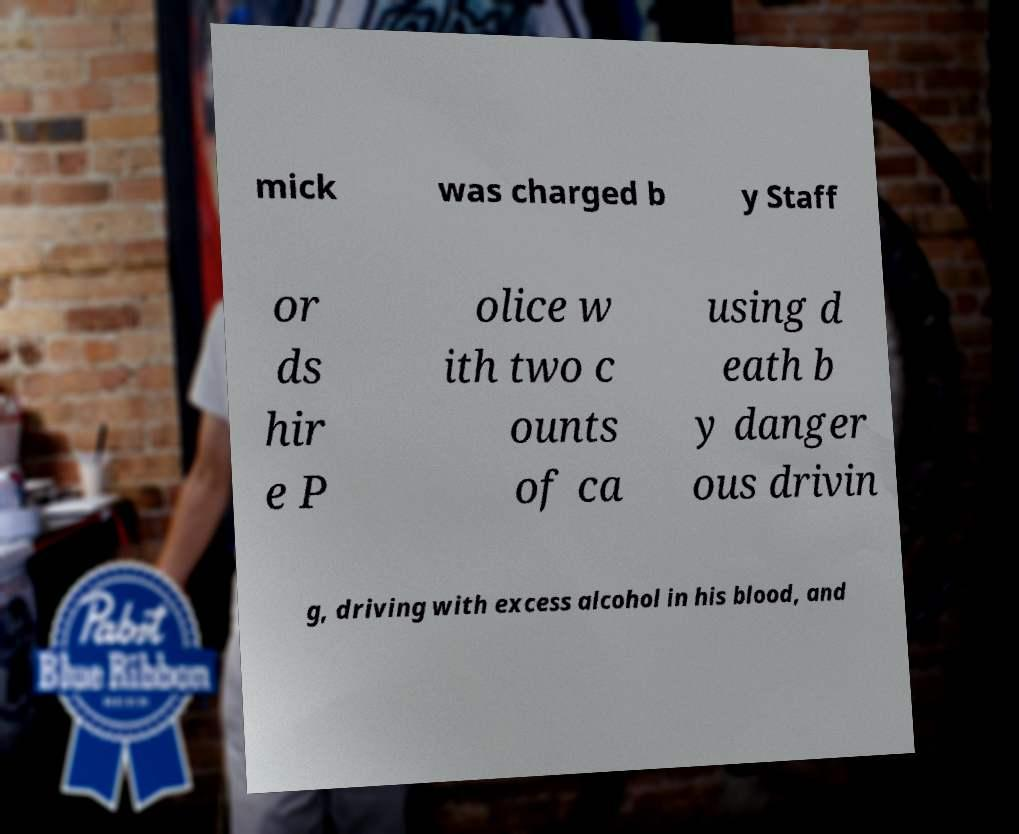Please identify and transcribe the text found in this image. mick was charged b y Staff or ds hir e P olice w ith two c ounts of ca using d eath b y danger ous drivin g, driving with excess alcohol in his blood, and 